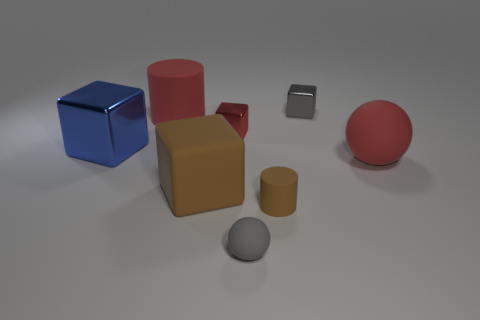There is a big brown rubber thing; does it have the same shape as the gray thing that is in front of the large sphere?
Offer a terse response. No. How many cylinders are either tiny rubber things or brown rubber objects?
Your answer should be very brief. 1. There is a gray object that is behind the tiny sphere; what is its shape?
Your answer should be compact. Cube. How many small brown cylinders have the same material as the big red cylinder?
Keep it short and to the point. 1. Is the number of large cylinders that are in front of the red cube less than the number of large brown objects?
Your answer should be very brief. Yes. There is a thing left of the cylinder that is to the left of the gray ball; what size is it?
Provide a short and direct response. Large. Do the large metal thing and the tiny object to the left of the tiny gray rubber object have the same color?
Your answer should be compact. No. There is a gray cube that is the same size as the red metal object; what material is it?
Make the answer very short. Metal. Are there fewer blue objects behind the small matte sphere than tiny things behind the tiny red shiny thing?
Offer a very short reply. No. What is the shape of the small metal object that is left of the sphere in front of the large sphere?
Offer a very short reply. Cube. 